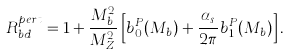Convert formula to latex. <formula><loc_0><loc_0><loc_500><loc_500>R _ { b d } ^ { p e r t } = 1 + \frac { M _ { b } ^ { 2 } } { M _ { Z } ^ { 2 } } \left [ b ^ { P } _ { 0 } ( M _ { b } ) + \frac { \alpha _ { s } } { 2 \pi } b ^ { P } _ { 1 } ( M _ { b } ) \right ] .</formula> 